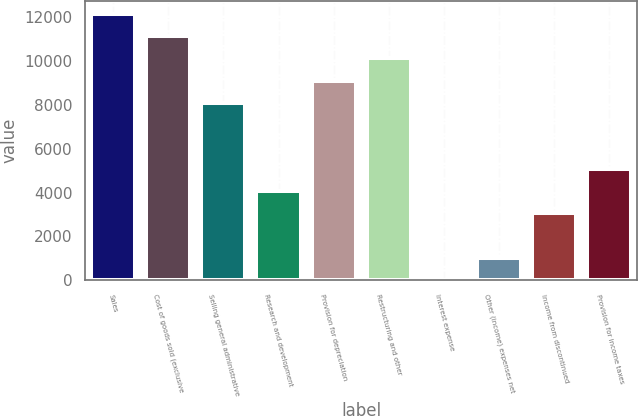<chart> <loc_0><loc_0><loc_500><loc_500><bar_chart><fcel>Sales<fcel>Cost of goods sold (exclusive<fcel>Selling general administrative<fcel>Research and development<fcel>Provision for depreciation<fcel>Restructuring and other<fcel>Interest expense<fcel>Other (income) expenses net<fcel>Income from discontinued<fcel>Provision for income taxes<nl><fcel>12140.2<fcel>11130.6<fcel>8101.8<fcel>4063.4<fcel>9111.4<fcel>10121<fcel>25<fcel>1034.6<fcel>3053.8<fcel>5073<nl></chart> 